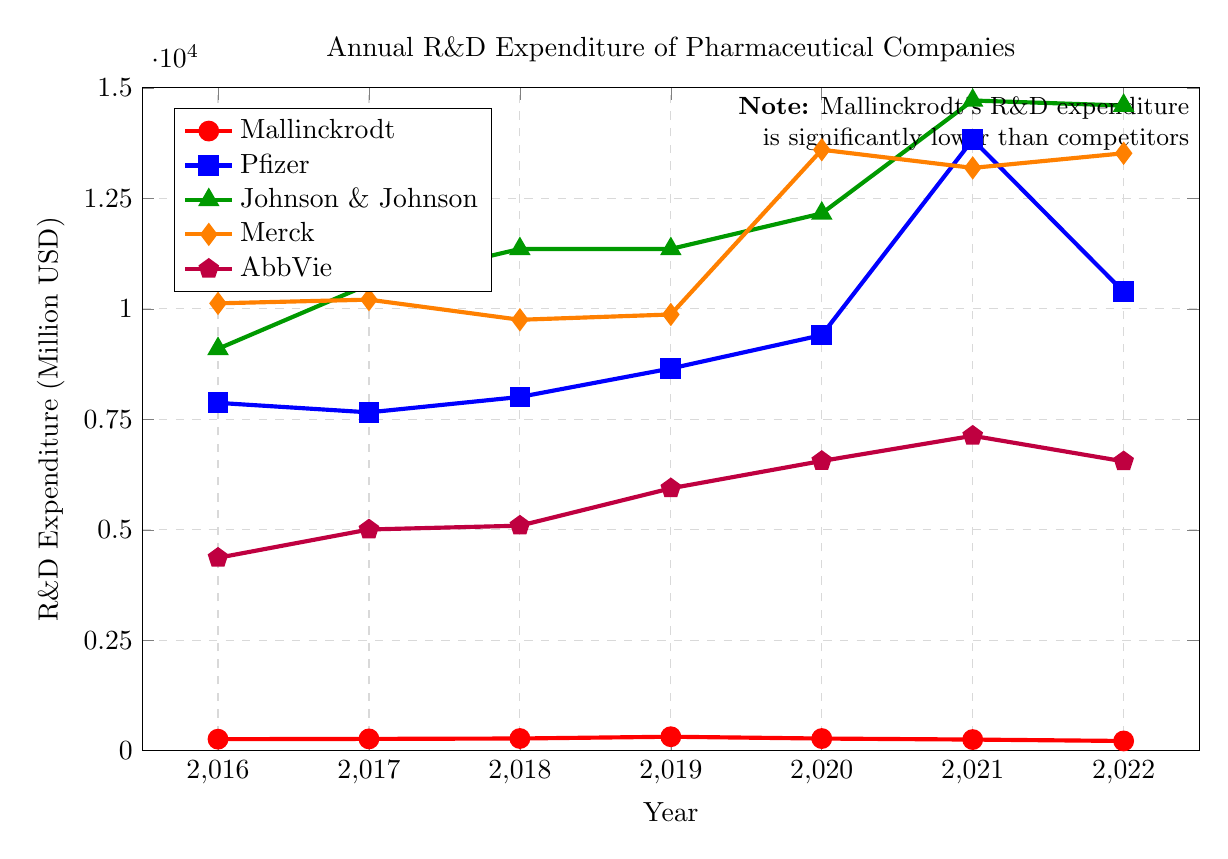What is the trend of Mallinckrodt's R&D expenditure from 2016 to 2022? By looking at the points and the labels on the line corresponding to Mallinckrodt (red line with circular markers), we can trace the values: 262 in 2016, 268 in 2017, 277 in 2018, 317 in 2019, 276 in 2020, 253 in 2021, and 221 in 2022. The expenditure showed a general upward trend until 2019 and then a downward trend from 2020 to 2022.
Answer: Decreasing overall from 2019 to 2022 Which company had the highest R&D expenditure in 2021? Observing the heights of the markers for each company in 2021, Johnson & Johnson (green triangle) stands out the most with an expenditure of 14714.
Answer: Johnson & Johnson By how much did Mallinckrodt's R&D expenditure decrease from 2019 to 2022? Find the R&D expenditure for Mallinckrodt for 2019 and 2022, i.e., 317 and 221 respectively. Subtract the two values: 317 - 221 = 96.
Answer: 96 million USD In what year did Merck have the highest R&D expenditure, and what was the value? By tracing the orange line corresponding to Merck, we find that the peak occurs in 2020 with an expenditure value of 13600.
Answer: 2020, 13600 million USD Compare the R&D expenditure of AbbVie and Pfizer in 2022. Which one had higher expenditure and by what amount? AbbVie's and Pfizer's expenditures in 2022 are 6548 and 10384 respectively. Subtracting AbbVie's expenditure from Pfizer's expenditure: 10384 - 6548 = 3836. Pfizer had the higher expenditure by 3836 million USD.
Answer: Pfizer, 3836 million USD What is the average annual R&D expenditure for Mallinckrodt between 2016 and 2022? Add all the annual expenditures for Mallinckrodt (262, 268, 277, 317, 276, 253, 221) and divide by the number of years (7): (262 + 268 + 277 + 317 + 276 + 253 + 221) / 7 = 253.43 million USD.
Answer: 253.43 million USD Which companies showed an increasing trend in their R&D expenditure from 2020 to 2021? Compare the 2020 versus 2021 values for each company:
- Mallinckrodt: 276 to 253 (decrease)
- Pfizer: 9405 to 13829 (increase)
- Johnson & Johnson: 12159 to 14714 (increase)
- Merck: 13600 to 13189 (decrease)
- AbbVie: 6557 to 7127 (increase)
Therefore, Pfizer, Johnson & Johnson, and AbbVie show an increasing trend.
Answer: Pfizer, Johnson & Johnson, AbbVie Which year did Pfizer see the largest increase in its R&D expenditure compared to the previous year? Calculate the yearly differences in Pfizer's R&D expenditures:
- 2017-2016: 7657 - 7872 = -215 (decrease)
- 2018-2017: 8006 - 7657 = 349
- 2019-2018: 8650 - 8006 = 644
- 2020-2019: 9405 - 8650 = 755
- 2021-2020: 13829 - 9405 = 4424
- 2022-2021: 10384 - 13829 = -3445 (decrease)
The largest increase is from 2020 to 2021 with an increase of 4424.
Answer: 2020 to 2021, 4424 million USD 